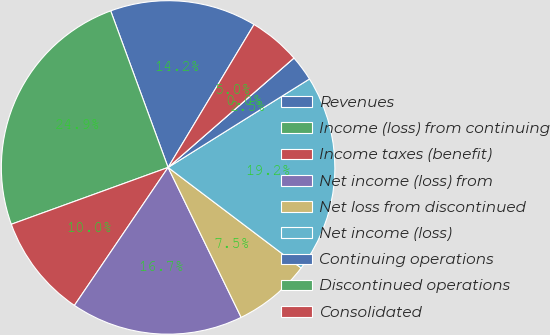Convert chart. <chart><loc_0><loc_0><loc_500><loc_500><pie_chart><fcel>Revenues<fcel>Income (loss) from continuing<fcel>Income taxes (benefit)<fcel>Net income (loss) from<fcel>Net loss from discontinued<fcel>Net income (loss)<fcel>Continuing operations<fcel>Discontinued operations<fcel>Consolidated<nl><fcel>14.21%<fcel>24.94%<fcel>9.97%<fcel>16.71%<fcel>7.48%<fcel>19.2%<fcel>2.49%<fcel>0.0%<fcel>4.99%<nl></chart> 